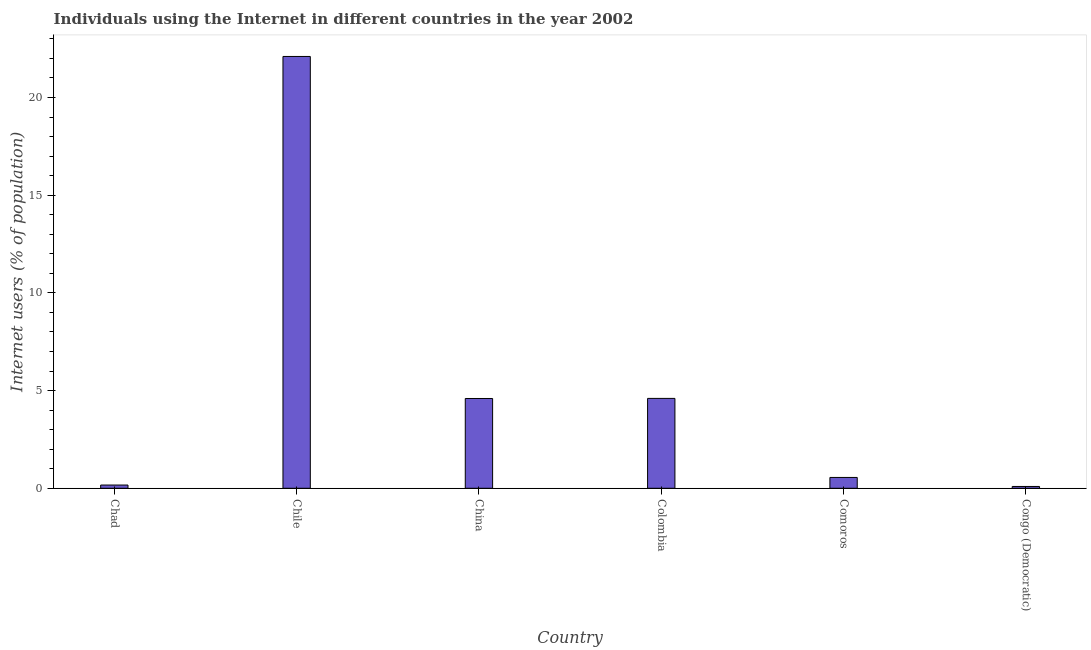What is the title of the graph?
Ensure brevity in your answer.  Individuals using the Internet in different countries in the year 2002. What is the label or title of the X-axis?
Give a very brief answer. Country. What is the label or title of the Y-axis?
Offer a very short reply. Internet users (% of population). What is the number of internet users in Chad?
Offer a terse response. 0.17. Across all countries, what is the maximum number of internet users?
Ensure brevity in your answer.  22.1. Across all countries, what is the minimum number of internet users?
Your response must be concise. 0.09. In which country was the number of internet users maximum?
Offer a very short reply. Chile. In which country was the number of internet users minimum?
Provide a succinct answer. Congo (Democratic). What is the sum of the number of internet users?
Offer a terse response. 32.11. What is the difference between the number of internet users in Chad and China?
Give a very brief answer. -4.43. What is the average number of internet users per country?
Make the answer very short. 5.35. What is the median number of internet users?
Make the answer very short. 2.58. In how many countries, is the number of internet users greater than 6 %?
Give a very brief answer. 1. What is the ratio of the number of internet users in China to that in Congo (Democratic)?
Keep it short and to the point. 49.53. What is the difference between the highest and the second highest number of internet users?
Keep it short and to the point. 17.5. Is the sum of the number of internet users in Chile and Colombia greater than the maximum number of internet users across all countries?
Your answer should be compact. Yes. What is the difference between the highest and the lowest number of internet users?
Your answer should be compact. 22.01. In how many countries, is the number of internet users greater than the average number of internet users taken over all countries?
Provide a succinct answer. 1. Are all the bars in the graph horizontal?
Ensure brevity in your answer.  No. How many countries are there in the graph?
Offer a terse response. 6. What is the difference between two consecutive major ticks on the Y-axis?
Give a very brief answer. 5. Are the values on the major ticks of Y-axis written in scientific E-notation?
Keep it short and to the point. No. What is the Internet users (% of population) in Chad?
Ensure brevity in your answer.  0.17. What is the Internet users (% of population) of Chile?
Your response must be concise. 22.1. What is the Internet users (% of population) of China?
Ensure brevity in your answer.  4.6. What is the Internet users (% of population) in Colombia?
Your response must be concise. 4.6. What is the Internet users (% of population) of Comoros?
Your response must be concise. 0.55. What is the Internet users (% of population) in Congo (Democratic)?
Your answer should be compact. 0.09. What is the difference between the Internet users (% of population) in Chad and Chile?
Make the answer very short. -21.93. What is the difference between the Internet users (% of population) in Chad and China?
Your answer should be very brief. -4.43. What is the difference between the Internet users (% of population) in Chad and Colombia?
Offer a terse response. -4.43. What is the difference between the Internet users (% of population) in Chad and Comoros?
Offer a terse response. -0.39. What is the difference between the Internet users (% of population) in Chad and Congo (Democratic)?
Provide a short and direct response. 0.07. What is the difference between the Internet users (% of population) in Chile and China?
Make the answer very short. 17.5. What is the difference between the Internet users (% of population) in Chile and Comoros?
Provide a succinct answer. 21.55. What is the difference between the Internet users (% of population) in Chile and Congo (Democratic)?
Ensure brevity in your answer.  22.01. What is the difference between the Internet users (% of population) in China and Colombia?
Offer a very short reply. -0. What is the difference between the Internet users (% of population) in China and Comoros?
Give a very brief answer. 4.04. What is the difference between the Internet users (% of population) in China and Congo (Democratic)?
Offer a very short reply. 4.5. What is the difference between the Internet users (% of population) in Colombia and Comoros?
Your response must be concise. 4.05. What is the difference between the Internet users (% of population) in Colombia and Congo (Democratic)?
Give a very brief answer. 4.51. What is the difference between the Internet users (% of population) in Comoros and Congo (Democratic)?
Your answer should be very brief. 0.46. What is the ratio of the Internet users (% of population) in Chad to that in Chile?
Offer a very short reply. 0.01. What is the ratio of the Internet users (% of population) in Chad to that in China?
Ensure brevity in your answer.  0.04. What is the ratio of the Internet users (% of population) in Chad to that in Colombia?
Your response must be concise. 0.04. What is the ratio of the Internet users (% of population) in Chad to that in Comoros?
Offer a terse response. 0.3. What is the ratio of the Internet users (% of population) in Chad to that in Congo (Democratic)?
Provide a short and direct response. 1.79. What is the ratio of the Internet users (% of population) in Chile to that in China?
Ensure brevity in your answer.  4.81. What is the ratio of the Internet users (% of population) in Chile to that in Colombia?
Ensure brevity in your answer.  4.8. What is the ratio of the Internet users (% of population) in Chile to that in Comoros?
Ensure brevity in your answer.  39.83. What is the ratio of the Internet users (% of population) in Chile to that in Congo (Democratic)?
Provide a succinct answer. 238.17. What is the ratio of the Internet users (% of population) in China to that in Comoros?
Your answer should be very brief. 8.28. What is the ratio of the Internet users (% of population) in China to that in Congo (Democratic)?
Offer a very short reply. 49.53. What is the ratio of the Internet users (% of population) in Colombia to that in Comoros?
Ensure brevity in your answer.  8.29. What is the ratio of the Internet users (% of population) in Colombia to that in Congo (Democratic)?
Your answer should be very brief. 49.57. What is the ratio of the Internet users (% of population) in Comoros to that in Congo (Democratic)?
Provide a short and direct response. 5.98. 